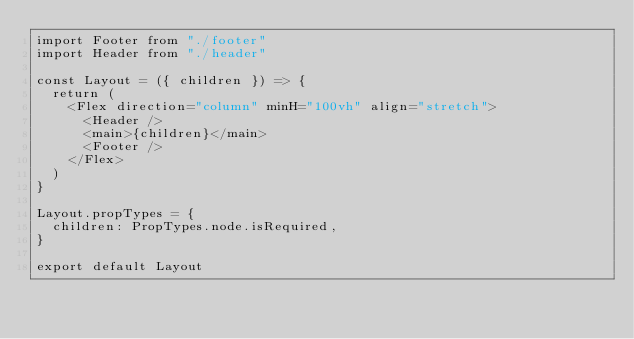Convert code to text. <code><loc_0><loc_0><loc_500><loc_500><_JavaScript_>import Footer from "./footer"
import Header from "./header"

const Layout = ({ children }) => {
  return (
    <Flex direction="column" minH="100vh" align="stretch">
      <Header />
      <main>{children}</main>
      <Footer />
    </Flex>
  )
}

Layout.propTypes = {
  children: PropTypes.node.isRequired,
}

export default Layout
</code> 